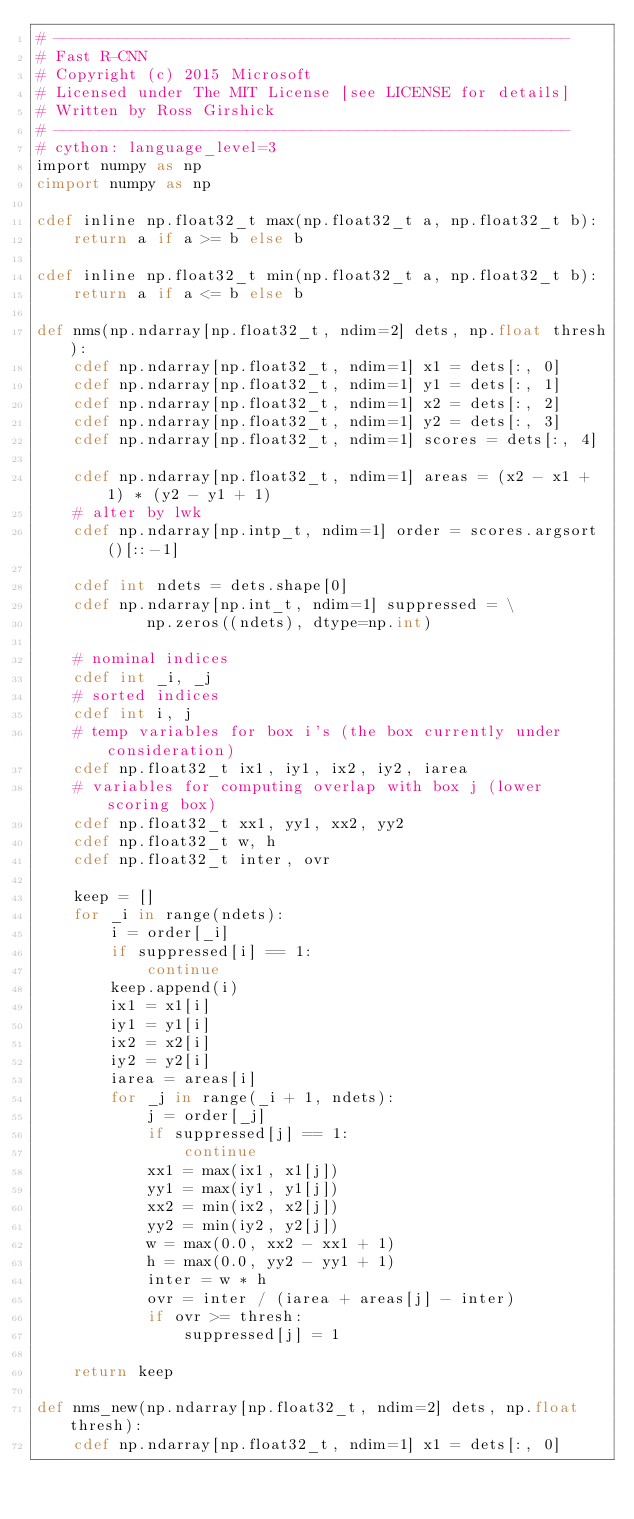Convert code to text. <code><loc_0><loc_0><loc_500><loc_500><_Cython_># --------------------------------------------------------
# Fast R-CNN
# Copyright (c) 2015 Microsoft
# Licensed under The MIT License [see LICENSE for details]
# Written by Ross Girshick
# --------------------------------------------------------
# cython: language_level=3
import numpy as np
cimport numpy as np

cdef inline np.float32_t max(np.float32_t a, np.float32_t b):
    return a if a >= b else b

cdef inline np.float32_t min(np.float32_t a, np.float32_t b):
    return a if a <= b else b

def nms(np.ndarray[np.float32_t, ndim=2] dets, np.float thresh):
    cdef np.ndarray[np.float32_t, ndim=1] x1 = dets[:, 0]
    cdef np.ndarray[np.float32_t, ndim=1] y1 = dets[:, 1]
    cdef np.ndarray[np.float32_t, ndim=1] x2 = dets[:, 2]
    cdef np.ndarray[np.float32_t, ndim=1] y2 = dets[:, 3]
    cdef np.ndarray[np.float32_t, ndim=1] scores = dets[:, 4]

    cdef np.ndarray[np.float32_t, ndim=1] areas = (x2 - x1 + 1) * (y2 - y1 + 1)
    # alter by lwk
    cdef np.ndarray[np.intp_t, ndim=1] order = scores.argsort()[::-1]

    cdef int ndets = dets.shape[0]
    cdef np.ndarray[np.int_t, ndim=1] suppressed = \
            np.zeros((ndets), dtype=np.int)

    # nominal indices
    cdef int _i, _j
    # sorted indices
    cdef int i, j
    # temp variables for box i's (the box currently under consideration)
    cdef np.float32_t ix1, iy1, ix2, iy2, iarea
    # variables for computing overlap with box j (lower scoring box)
    cdef np.float32_t xx1, yy1, xx2, yy2
    cdef np.float32_t w, h
    cdef np.float32_t inter, ovr

    keep = []
    for _i in range(ndets):
        i = order[_i]
        if suppressed[i] == 1:
            continue
        keep.append(i)
        ix1 = x1[i]
        iy1 = y1[i]
        ix2 = x2[i]
        iy2 = y2[i]
        iarea = areas[i]
        for _j in range(_i + 1, ndets):
            j = order[_j]
            if suppressed[j] == 1:
                continue
            xx1 = max(ix1, x1[j])
            yy1 = max(iy1, y1[j])
            xx2 = min(ix2, x2[j])
            yy2 = min(iy2, y2[j])
            w = max(0.0, xx2 - xx1 + 1)
            h = max(0.0, yy2 - yy1 + 1)
            inter = w * h
            ovr = inter / (iarea + areas[j] - inter)
            if ovr >= thresh:
                suppressed[j] = 1

    return keep

def nms_new(np.ndarray[np.float32_t, ndim=2] dets, np.float thresh):
    cdef np.ndarray[np.float32_t, ndim=1] x1 = dets[:, 0]</code> 